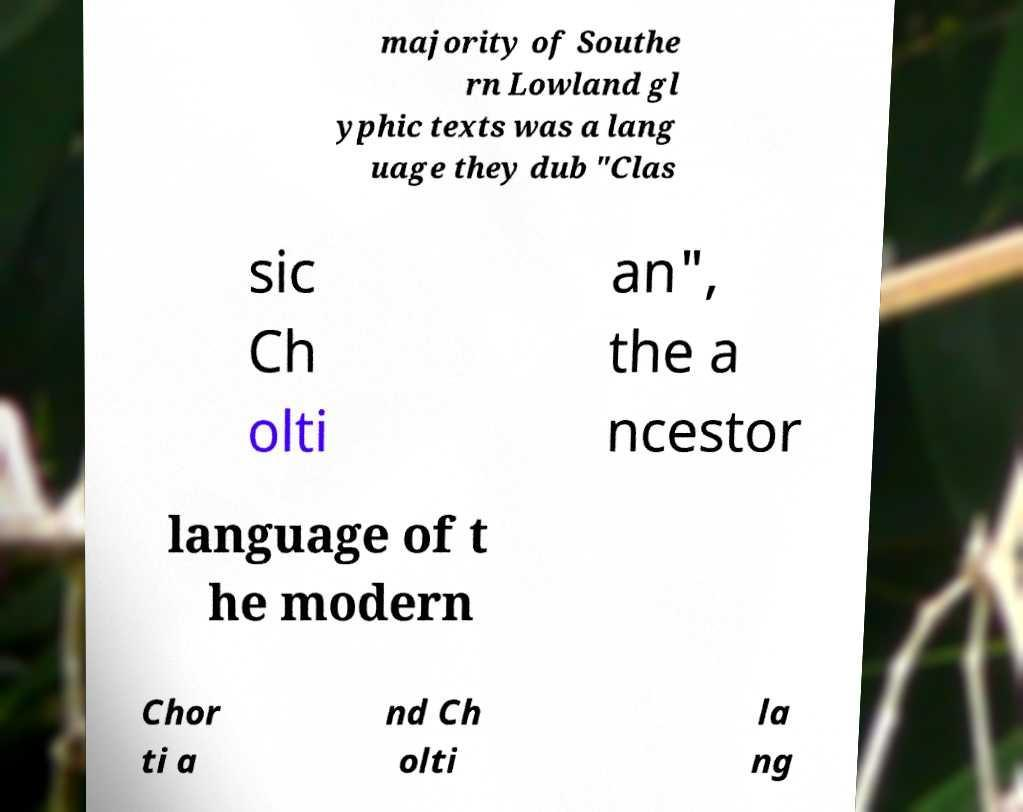I need the written content from this picture converted into text. Can you do that? majority of Southe rn Lowland gl yphic texts was a lang uage they dub "Clas sic Ch olti an", the a ncestor language of t he modern Chor ti a nd Ch olti la ng 